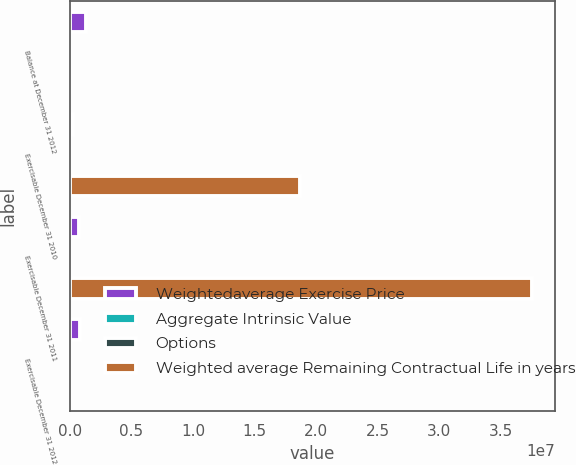Convert chart. <chart><loc_0><loc_0><loc_500><loc_500><stacked_bar_chart><ecel><fcel>Balance at December 31 2012<fcel>Exercisable December 31 2010<fcel>Exercisable December 31 2011<fcel>Exercisable December 31 2012<nl><fcel>Weightedaverage Exercise Price<fcel>1.30917e+06<fcel>222110<fcel>721210<fcel>785869<nl><fcel>Aggregate Intrinsic Value<fcel>78.8<fcel>26.36<fcel>38.75<fcel>51.4<nl><fcel>Options<fcel>7.3<fcel>5.4<fcel>6.25<fcel>6.26<nl><fcel>Weighted average Remaining Contractual Life in years<fcel>65.1<fcel>1.8684e+07<fcel>3.75265e+07<fcel>65.1<nl></chart> 